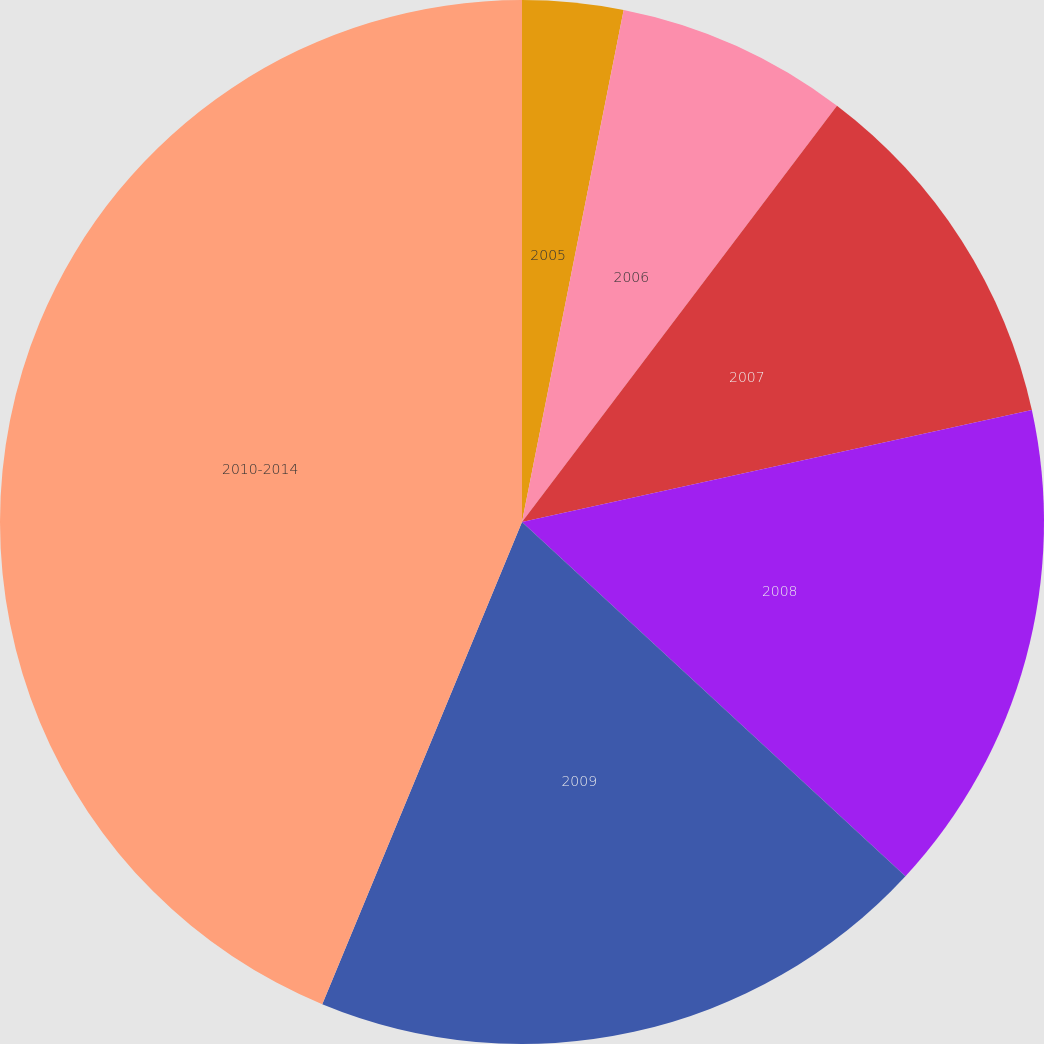Convert chart. <chart><loc_0><loc_0><loc_500><loc_500><pie_chart><fcel>2005<fcel>2006<fcel>2007<fcel>2008<fcel>2009<fcel>2010-2014<nl><fcel>3.12%<fcel>7.19%<fcel>11.25%<fcel>15.31%<fcel>19.38%<fcel>43.75%<nl></chart> 